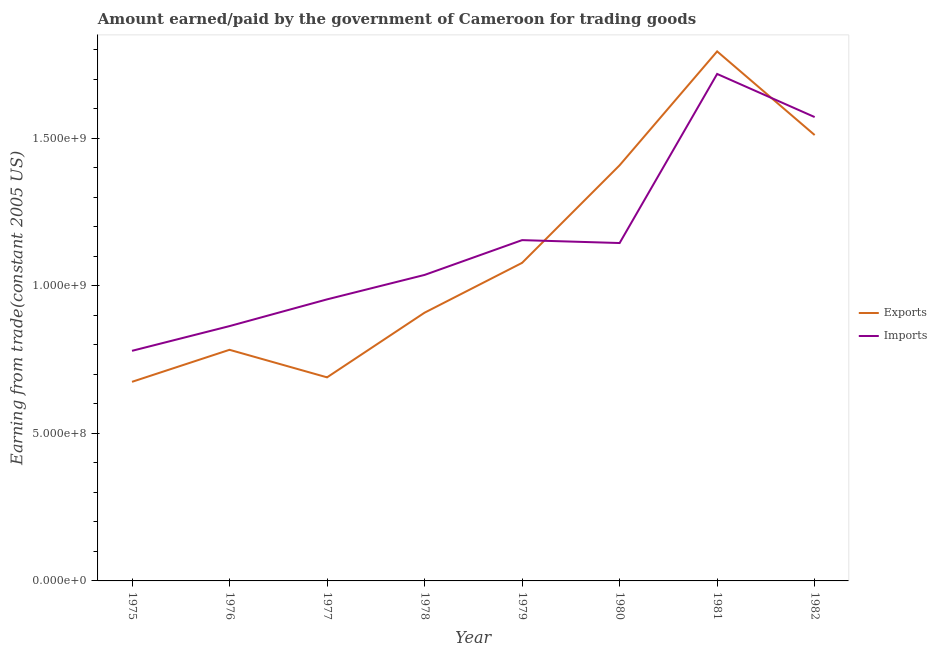Does the line corresponding to amount paid for imports intersect with the line corresponding to amount earned from exports?
Offer a very short reply. Yes. Is the number of lines equal to the number of legend labels?
Provide a succinct answer. Yes. What is the amount earned from exports in 1982?
Provide a succinct answer. 1.51e+09. Across all years, what is the maximum amount paid for imports?
Provide a succinct answer. 1.72e+09. Across all years, what is the minimum amount paid for imports?
Provide a short and direct response. 7.79e+08. In which year was the amount earned from exports minimum?
Make the answer very short. 1975. What is the total amount paid for imports in the graph?
Make the answer very short. 9.22e+09. What is the difference between the amount earned from exports in 1975 and that in 1982?
Ensure brevity in your answer.  -8.36e+08. What is the difference between the amount paid for imports in 1982 and the amount earned from exports in 1978?
Your response must be concise. 6.63e+08. What is the average amount earned from exports per year?
Offer a terse response. 1.11e+09. In the year 1980, what is the difference between the amount paid for imports and amount earned from exports?
Provide a short and direct response. -2.63e+08. In how many years, is the amount paid for imports greater than 1200000000 US$?
Provide a succinct answer. 2. What is the ratio of the amount paid for imports in 1975 to that in 1978?
Ensure brevity in your answer.  0.75. Is the difference between the amount earned from exports in 1977 and 1979 greater than the difference between the amount paid for imports in 1977 and 1979?
Your response must be concise. No. What is the difference between the highest and the second highest amount earned from exports?
Make the answer very short. 2.83e+08. What is the difference between the highest and the lowest amount paid for imports?
Make the answer very short. 9.38e+08. Is the sum of the amount paid for imports in 1975 and 1977 greater than the maximum amount earned from exports across all years?
Your response must be concise. No. Does the amount paid for imports monotonically increase over the years?
Offer a terse response. No. Is the amount paid for imports strictly less than the amount earned from exports over the years?
Keep it short and to the point. No. How many lines are there?
Give a very brief answer. 2. How many years are there in the graph?
Offer a terse response. 8. Does the graph contain grids?
Offer a terse response. No. Where does the legend appear in the graph?
Provide a succinct answer. Center right. How many legend labels are there?
Give a very brief answer. 2. How are the legend labels stacked?
Give a very brief answer. Vertical. What is the title of the graph?
Give a very brief answer. Amount earned/paid by the government of Cameroon for trading goods. Does "Banks" appear as one of the legend labels in the graph?
Offer a terse response. No. What is the label or title of the X-axis?
Keep it short and to the point. Year. What is the label or title of the Y-axis?
Make the answer very short. Earning from trade(constant 2005 US). What is the Earning from trade(constant 2005 US) in Exports in 1975?
Give a very brief answer. 6.74e+08. What is the Earning from trade(constant 2005 US) of Imports in 1975?
Your answer should be compact. 7.79e+08. What is the Earning from trade(constant 2005 US) of Exports in 1976?
Your answer should be very brief. 7.83e+08. What is the Earning from trade(constant 2005 US) of Imports in 1976?
Provide a succinct answer. 8.63e+08. What is the Earning from trade(constant 2005 US) in Exports in 1977?
Keep it short and to the point. 6.90e+08. What is the Earning from trade(constant 2005 US) of Imports in 1977?
Your response must be concise. 9.54e+08. What is the Earning from trade(constant 2005 US) in Exports in 1978?
Make the answer very short. 9.09e+08. What is the Earning from trade(constant 2005 US) of Imports in 1978?
Offer a very short reply. 1.04e+09. What is the Earning from trade(constant 2005 US) of Exports in 1979?
Give a very brief answer. 1.08e+09. What is the Earning from trade(constant 2005 US) of Imports in 1979?
Offer a terse response. 1.15e+09. What is the Earning from trade(constant 2005 US) of Exports in 1980?
Give a very brief answer. 1.41e+09. What is the Earning from trade(constant 2005 US) of Imports in 1980?
Provide a short and direct response. 1.14e+09. What is the Earning from trade(constant 2005 US) of Exports in 1981?
Ensure brevity in your answer.  1.79e+09. What is the Earning from trade(constant 2005 US) of Imports in 1981?
Your answer should be very brief. 1.72e+09. What is the Earning from trade(constant 2005 US) of Exports in 1982?
Your answer should be very brief. 1.51e+09. What is the Earning from trade(constant 2005 US) in Imports in 1982?
Give a very brief answer. 1.57e+09. Across all years, what is the maximum Earning from trade(constant 2005 US) of Exports?
Provide a short and direct response. 1.79e+09. Across all years, what is the maximum Earning from trade(constant 2005 US) in Imports?
Your answer should be compact. 1.72e+09. Across all years, what is the minimum Earning from trade(constant 2005 US) in Exports?
Ensure brevity in your answer.  6.74e+08. Across all years, what is the minimum Earning from trade(constant 2005 US) of Imports?
Give a very brief answer. 7.79e+08. What is the total Earning from trade(constant 2005 US) of Exports in the graph?
Your response must be concise. 8.84e+09. What is the total Earning from trade(constant 2005 US) of Imports in the graph?
Make the answer very short. 9.22e+09. What is the difference between the Earning from trade(constant 2005 US) of Exports in 1975 and that in 1976?
Your answer should be compact. -1.08e+08. What is the difference between the Earning from trade(constant 2005 US) in Imports in 1975 and that in 1976?
Your answer should be compact. -8.37e+07. What is the difference between the Earning from trade(constant 2005 US) of Exports in 1975 and that in 1977?
Keep it short and to the point. -1.51e+07. What is the difference between the Earning from trade(constant 2005 US) in Imports in 1975 and that in 1977?
Give a very brief answer. -1.74e+08. What is the difference between the Earning from trade(constant 2005 US) in Exports in 1975 and that in 1978?
Your answer should be compact. -2.34e+08. What is the difference between the Earning from trade(constant 2005 US) of Imports in 1975 and that in 1978?
Your answer should be compact. -2.57e+08. What is the difference between the Earning from trade(constant 2005 US) of Exports in 1975 and that in 1979?
Offer a terse response. -4.03e+08. What is the difference between the Earning from trade(constant 2005 US) in Imports in 1975 and that in 1979?
Your answer should be very brief. -3.75e+08. What is the difference between the Earning from trade(constant 2005 US) in Exports in 1975 and that in 1980?
Provide a succinct answer. -7.33e+08. What is the difference between the Earning from trade(constant 2005 US) in Imports in 1975 and that in 1980?
Give a very brief answer. -3.65e+08. What is the difference between the Earning from trade(constant 2005 US) of Exports in 1975 and that in 1981?
Ensure brevity in your answer.  -1.12e+09. What is the difference between the Earning from trade(constant 2005 US) of Imports in 1975 and that in 1981?
Offer a terse response. -9.38e+08. What is the difference between the Earning from trade(constant 2005 US) in Exports in 1975 and that in 1982?
Provide a succinct answer. -8.36e+08. What is the difference between the Earning from trade(constant 2005 US) in Imports in 1975 and that in 1982?
Your answer should be very brief. -7.92e+08. What is the difference between the Earning from trade(constant 2005 US) of Exports in 1976 and that in 1977?
Ensure brevity in your answer.  9.33e+07. What is the difference between the Earning from trade(constant 2005 US) in Imports in 1976 and that in 1977?
Keep it short and to the point. -9.05e+07. What is the difference between the Earning from trade(constant 2005 US) of Exports in 1976 and that in 1978?
Provide a succinct answer. -1.26e+08. What is the difference between the Earning from trade(constant 2005 US) of Imports in 1976 and that in 1978?
Your answer should be very brief. -1.73e+08. What is the difference between the Earning from trade(constant 2005 US) of Exports in 1976 and that in 1979?
Ensure brevity in your answer.  -2.94e+08. What is the difference between the Earning from trade(constant 2005 US) in Imports in 1976 and that in 1979?
Make the answer very short. -2.91e+08. What is the difference between the Earning from trade(constant 2005 US) of Exports in 1976 and that in 1980?
Offer a terse response. -6.25e+08. What is the difference between the Earning from trade(constant 2005 US) of Imports in 1976 and that in 1980?
Offer a very short reply. -2.81e+08. What is the difference between the Earning from trade(constant 2005 US) of Exports in 1976 and that in 1981?
Offer a terse response. -1.01e+09. What is the difference between the Earning from trade(constant 2005 US) of Imports in 1976 and that in 1981?
Your answer should be compact. -8.54e+08. What is the difference between the Earning from trade(constant 2005 US) of Exports in 1976 and that in 1982?
Offer a very short reply. -7.27e+08. What is the difference between the Earning from trade(constant 2005 US) in Imports in 1976 and that in 1982?
Keep it short and to the point. -7.08e+08. What is the difference between the Earning from trade(constant 2005 US) of Exports in 1977 and that in 1978?
Make the answer very short. -2.19e+08. What is the difference between the Earning from trade(constant 2005 US) in Imports in 1977 and that in 1978?
Provide a short and direct response. -8.28e+07. What is the difference between the Earning from trade(constant 2005 US) of Exports in 1977 and that in 1979?
Keep it short and to the point. -3.88e+08. What is the difference between the Earning from trade(constant 2005 US) in Imports in 1977 and that in 1979?
Offer a terse response. -2.01e+08. What is the difference between the Earning from trade(constant 2005 US) in Exports in 1977 and that in 1980?
Give a very brief answer. -7.18e+08. What is the difference between the Earning from trade(constant 2005 US) of Imports in 1977 and that in 1980?
Give a very brief answer. -1.91e+08. What is the difference between the Earning from trade(constant 2005 US) in Exports in 1977 and that in 1981?
Keep it short and to the point. -1.10e+09. What is the difference between the Earning from trade(constant 2005 US) of Imports in 1977 and that in 1981?
Offer a terse response. -7.64e+08. What is the difference between the Earning from trade(constant 2005 US) in Exports in 1977 and that in 1982?
Offer a very short reply. -8.21e+08. What is the difference between the Earning from trade(constant 2005 US) of Imports in 1977 and that in 1982?
Provide a succinct answer. -6.18e+08. What is the difference between the Earning from trade(constant 2005 US) of Exports in 1978 and that in 1979?
Provide a succinct answer. -1.69e+08. What is the difference between the Earning from trade(constant 2005 US) of Imports in 1978 and that in 1979?
Offer a terse response. -1.18e+08. What is the difference between the Earning from trade(constant 2005 US) of Exports in 1978 and that in 1980?
Offer a terse response. -4.99e+08. What is the difference between the Earning from trade(constant 2005 US) in Imports in 1978 and that in 1980?
Offer a terse response. -1.08e+08. What is the difference between the Earning from trade(constant 2005 US) in Exports in 1978 and that in 1981?
Your answer should be very brief. -8.85e+08. What is the difference between the Earning from trade(constant 2005 US) of Imports in 1978 and that in 1981?
Provide a succinct answer. -6.81e+08. What is the difference between the Earning from trade(constant 2005 US) in Exports in 1978 and that in 1982?
Provide a succinct answer. -6.02e+08. What is the difference between the Earning from trade(constant 2005 US) in Imports in 1978 and that in 1982?
Your response must be concise. -5.35e+08. What is the difference between the Earning from trade(constant 2005 US) in Exports in 1979 and that in 1980?
Provide a short and direct response. -3.31e+08. What is the difference between the Earning from trade(constant 2005 US) in Imports in 1979 and that in 1980?
Make the answer very short. 9.83e+06. What is the difference between the Earning from trade(constant 2005 US) in Exports in 1979 and that in 1981?
Your answer should be very brief. -7.16e+08. What is the difference between the Earning from trade(constant 2005 US) in Imports in 1979 and that in 1981?
Ensure brevity in your answer.  -5.63e+08. What is the difference between the Earning from trade(constant 2005 US) of Exports in 1979 and that in 1982?
Offer a terse response. -4.33e+08. What is the difference between the Earning from trade(constant 2005 US) in Imports in 1979 and that in 1982?
Keep it short and to the point. -4.17e+08. What is the difference between the Earning from trade(constant 2005 US) of Exports in 1980 and that in 1981?
Keep it short and to the point. -3.86e+08. What is the difference between the Earning from trade(constant 2005 US) of Imports in 1980 and that in 1981?
Your response must be concise. -5.73e+08. What is the difference between the Earning from trade(constant 2005 US) in Exports in 1980 and that in 1982?
Keep it short and to the point. -1.02e+08. What is the difference between the Earning from trade(constant 2005 US) of Imports in 1980 and that in 1982?
Offer a terse response. -4.27e+08. What is the difference between the Earning from trade(constant 2005 US) in Exports in 1981 and that in 1982?
Provide a succinct answer. 2.83e+08. What is the difference between the Earning from trade(constant 2005 US) of Imports in 1981 and that in 1982?
Provide a succinct answer. 1.46e+08. What is the difference between the Earning from trade(constant 2005 US) of Exports in 1975 and the Earning from trade(constant 2005 US) of Imports in 1976?
Give a very brief answer. -1.89e+08. What is the difference between the Earning from trade(constant 2005 US) of Exports in 1975 and the Earning from trade(constant 2005 US) of Imports in 1977?
Offer a terse response. -2.79e+08. What is the difference between the Earning from trade(constant 2005 US) of Exports in 1975 and the Earning from trade(constant 2005 US) of Imports in 1978?
Your answer should be compact. -3.62e+08. What is the difference between the Earning from trade(constant 2005 US) in Exports in 1975 and the Earning from trade(constant 2005 US) in Imports in 1979?
Make the answer very short. -4.80e+08. What is the difference between the Earning from trade(constant 2005 US) of Exports in 1975 and the Earning from trade(constant 2005 US) of Imports in 1980?
Your answer should be very brief. -4.70e+08. What is the difference between the Earning from trade(constant 2005 US) in Exports in 1975 and the Earning from trade(constant 2005 US) in Imports in 1981?
Make the answer very short. -1.04e+09. What is the difference between the Earning from trade(constant 2005 US) of Exports in 1975 and the Earning from trade(constant 2005 US) of Imports in 1982?
Offer a terse response. -8.97e+08. What is the difference between the Earning from trade(constant 2005 US) of Exports in 1976 and the Earning from trade(constant 2005 US) of Imports in 1977?
Provide a succinct answer. -1.71e+08. What is the difference between the Earning from trade(constant 2005 US) in Exports in 1976 and the Earning from trade(constant 2005 US) in Imports in 1978?
Offer a terse response. -2.54e+08. What is the difference between the Earning from trade(constant 2005 US) of Exports in 1976 and the Earning from trade(constant 2005 US) of Imports in 1979?
Ensure brevity in your answer.  -3.71e+08. What is the difference between the Earning from trade(constant 2005 US) of Exports in 1976 and the Earning from trade(constant 2005 US) of Imports in 1980?
Provide a succinct answer. -3.62e+08. What is the difference between the Earning from trade(constant 2005 US) of Exports in 1976 and the Earning from trade(constant 2005 US) of Imports in 1981?
Give a very brief answer. -9.34e+08. What is the difference between the Earning from trade(constant 2005 US) of Exports in 1976 and the Earning from trade(constant 2005 US) of Imports in 1982?
Offer a very short reply. -7.88e+08. What is the difference between the Earning from trade(constant 2005 US) of Exports in 1977 and the Earning from trade(constant 2005 US) of Imports in 1978?
Keep it short and to the point. -3.47e+08. What is the difference between the Earning from trade(constant 2005 US) in Exports in 1977 and the Earning from trade(constant 2005 US) in Imports in 1979?
Provide a short and direct response. -4.65e+08. What is the difference between the Earning from trade(constant 2005 US) in Exports in 1977 and the Earning from trade(constant 2005 US) in Imports in 1980?
Ensure brevity in your answer.  -4.55e+08. What is the difference between the Earning from trade(constant 2005 US) of Exports in 1977 and the Earning from trade(constant 2005 US) of Imports in 1981?
Your response must be concise. -1.03e+09. What is the difference between the Earning from trade(constant 2005 US) in Exports in 1977 and the Earning from trade(constant 2005 US) in Imports in 1982?
Provide a succinct answer. -8.82e+08. What is the difference between the Earning from trade(constant 2005 US) in Exports in 1978 and the Earning from trade(constant 2005 US) in Imports in 1979?
Your response must be concise. -2.46e+08. What is the difference between the Earning from trade(constant 2005 US) of Exports in 1978 and the Earning from trade(constant 2005 US) of Imports in 1980?
Your answer should be compact. -2.36e+08. What is the difference between the Earning from trade(constant 2005 US) of Exports in 1978 and the Earning from trade(constant 2005 US) of Imports in 1981?
Ensure brevity in your answer.  -8.09e+08. What is the difference between the Earning from trade(constant 2005 US) in Exports in 1978 and the Earning from trade(constant 2005 US) in Imports in 1982?
Your answer should be compact. -6.63e+08. What is the difference between the Earning from trade(constant 2005 US) in Exports in 1979 and the Earning from trade(constant 2005 US) in Imports in 1980?
Offer a very short reply. -6.72e+07. What is the difference between the Earning from trade(constant 2005 US) in Exports in 1979 and the Earning from trade(constant 2005 US) in Imports in 1981?
Your answer should be very brief. -6.40e+08. What is the difference between the Earning from trade(constant 2005 US) in Exports in 1979 and the Earning from trade(constant 2005 US) in Imports in 1982?
Ensure brevity in your answer.  -4.94e+08. What is the difference between the Earning from trade(constant 2005 US) of Exports in 1980 and the Earning from trade(constant 2005 US) of Imports in 1981?
Provide a succinct answer. -3.09e+08. What is the difference between the Earning from trade(constant 2005 US) of Exports in 1980 and the Earning from trade(constant 2005 US) of Imports in 1982?
Offer a terse response. -1.63e+08. What is the difference between the Earning from trade(constant 2005 US) in Exports in 1981 and the Earning from trade(constant 2005 US) in Imports in 1982?
Your response must be concise. 2.22e+08. What is the average Earning from trade(constant 2005 US) of Exports per year?
Offer a very short reply. 1.11e+09. What is the average Earning from trade(constant 2005 US) in Imports per year?
Offer a very short reply. 1.15e+09. In the year 1975, what is the difference between the Earning from trade(constant 2005 US) in Exports and Earning from trade(constant 2005 US) in Imports?
Keep it short and to the point. -1.05e+08. In the year 1976, what is the difference between the Earning from trade(constant 2005 US) in Exports and Earning from trade(constant 2005 US) in Imports?
Your answer should be compact. -8.03e+07. In the year 1977, what is the difference between the Earning from trade(constant 2005 US) in Exports and Earning from trade(constant 2005 US) in Imports?
Your answer should be very brief. -2.64e+08. In the year 1978, what is the difference between the Earning from trade(constant 2005 US) of Exports and Earning from trade(constant 2005 US) of Imports?
Offer a terse response. -1.28e+08. In the year 1979, what is the difference between the Earning from trade(constant 2005 US) of Exports and Earning from trade(constant 2005 US) of Imports?
Keep it short and to the point. -7.70e+07. In the year 1980, what is the difference between the Earning from trade(constant 2005 US) in Exports and Earning from trade(constant 2005 US) in Imports?
Provide a short and direct response. 2.63e+08. In the year 1981, what is the difference between the Earning from trade(constant 2005 US) in Exports and Earning from trade(constant 2005 US) in Imports?
Provide a short and direct response. 7.64e+07. In the year 1982, what is the difference between the Earning from trade(constant 2005 US) in Exports and Earning from trade(constant 2005 US) in Imports?
Make the answer very short. -6.09e+07. What is the ratio of the Earning from trade(constant 2005 US) of Exports in 1975 to that in 1976?
Your answer should be very brief. 0.86. What is the ratio of the Earning from trade(constant 2005 US) in Imports in 1975 to that in 1976?
Provide a short and direct response. 0.9. What is the ratio of the Earning from trade(constant 2005 US) of Imports in 1975 to that in 1977?
Provide a short and direct response. 0.82. What is the ratio of the Earning from trade(constant 2005 US) of Exports in 1975 to that in 1978?
Give a very brief answer. 0.74. What is the ratio of the Earning from trade(constant 2005 US) of Imports in 1975 to that in 1978?
Keep it short and to the point. 0.75. What is the ratio of the Earning from trade(constant 2005 US) of Exports in 1975 to that in 1979?
Provide a short and direct response. 0.63. What is the ratio of the Earning from trade(constant 2005 US) of Imports in 1975 to that in 1979?
Provide a succinct answer. 0.68. What is the ratio of the Earning from trade(constant 2005 US) in Exports in 1975 to that in 1980?
Give a very brief answer. 0.48. What is the ratio of the Earning from trade(constant 2005 US) in Imports in 1975 to that in 1980?
Offer a very short reply. 0.68. What is the ratio of the Earning from trade(constant 2005 US) in Exports in 1975 to that in 1981?
Ensure brevity in your answer.  0.38. What is the ratio of the Earning from trade(constant 2005 US) of Imports in 1975 to that in 1981?
Offer a terse response. 0.45. What is the ratio of the Earning from trade(constant 2005 US) in Exports in 1975 to that in 1982?
Offer a terse response. 0.45. What is the ratio of the Earning from trade(constant 2005 US) in Imports in 1975 to that in 1982?
Make the answer very short. 0.5. What is the ratio of the Earning from trade(constant 2005 US) in Exports in 1976 to that in 1977?
Provide a succinct answer. 1.14. What is the ratio of the Earning from trade(constant 2005 US) of Imports in 1976 to that in 1977?
Your answer should be compact. 0.91. What is the ratio of the Earning from trade(constant 2005 US) of Exports in 1976 to that in 1978?
Give a very brief answer. 0.86. What is the ratio of the Earning from trade(constant 2005 US) in Imports in 1976 to that in 1978?
Keep it short and to the point. 0.83. What is the ratio of the Earning from trade(constant 2005 US) in Exports in 1976 to that in 1979?
Provide a short and direct response. 0.73. What is the ratio of the Earning from trade(constant 2005 US) in Imports in 1976 to that in 1979?
Give a very brief answer. 0.75. What is the ratio of the Earning from trade(constant 2005 US) of Exports in 1976 to that in 1980?
Keep it short and to the point. 0.56. What is the ratio of the Earning from trade(constant 2005 US) of Imports in 1976 to that in 1980?
Ensure brevity in your answer.  0.75. What is the ratio of the Earning from trade(constant 2005 US) in Exports in 1976 to that in 1981?
Give a very brief answer. 0.44. What is the ratio of the Earning from trade(constant 2005 US) of Imports in 1976 to that in 1981?
Keep it short and to the point. 0.5. What is the ratio of the Earning from trade(constant 2005 US) of Exports in 1976 to that in 1982?
Ensure brevity in your answer.  0.52. What is the ratio of the Earning from trade(constant 2005 US) in Imports in 1976 to that in 1982?
Give a very brief answer. 0.55. What is the ratio of the Earning from trade(constant 2005 US) in Exports in 1977 to that in 1978?
Provide a short and direct response. 0.76. What is the ratio of the Earning from trade(constant 2005 US) in Imports in 1977 to that in 1978?
Provide a succinct answer. 0.92. What is the ratio of the Earning from trade(constant 2005 US) of Exports in 1977 to that in 1979?
Make the answer very short. 0.64. What is the ratio of the Earning from trade(constant 2005 US) in Imports in 1977 to that in 1979?
Offer a very short reply. 0.83. What is the ratio of the Earning from trade(constant 2005 US) of Exports in 1977 to that in 1980?
Provide a short and direct response. 0.49. What is the ratio of the Earning from trade(constant 2005 US) of Imports in 1977 to that in 1980?
Your answer should be very brief. 0.83. What is the ratio of the Earning from trade(constant 2005 US) of Exports in 1977 to that in 1981?
Keep it short and to the point. 0.38. What is the ratio of the Earning from trade(constant 2005 US) in Imports in 1977 to that in 1981?
Offer a very short reply. 0.56. What is the ratio of the Earning from trade(constant 2005 US) in Exports in 1977 to that in 1982?
Provide a succinct answer. 0.46. What is the ratio of the Earning from trade(constant 2005 US) in Imports in 1977 to that in 1982?
Your response must be concise. 0.61. What is the ratio of the Earning from trade(constant 2005 US) of Exports in 1978 to that in 1979?
Your response must be concise. 0.84. What is the ratio of the Earning from trade(constant 2005 US) in Imports in 1978 to that in 1979?
Your response must be concise. 0.9. What is the ratio of the Earning from trade(constant 2005 US) of Exports in 1978 to that in 1980?
Keep it short and to the point. 0.65. What is the ratio of the Earning from trade(constant 2005 US) in Imports in 1978 to that in 1980?
Provide a short and direct response. 0.91. What is the ratio of the Earning from trade(constant 2005 US) of Exports in 1978 to that in 1981?
Offer a terse response. 0.51. What is the ratio of the Earning from trade(constant 2005 US) of Imports in 1978 to that in 1981?
Make the answer very short. 0.6. What is the ratio of the Earning from trade(constant 2005 US) in Exports in 1978 to that in 1982?
Make the answer very short. 0.6. What is the ratio of the Earning from trade(constant 2005 US) in Imports in 1978 to that in 1982?
Your response must be concise. 0.66. What is the ratio of the Earning from trade(constant 2005 US) in Exports in 1979 to that in 1980?
Give a very brief answer. 0.77. What is the ratio of the Earning from trade(constant 2005 US) in Imports in 1979 to that in 1980?
Ensure brevity in your answer.  1.01. What is the ratio of the Earning from trade(constant 2005 US) of Exports in 1979 to that in 1981?
Offer a terse response. 0.6. What is the ratio of the Earning from trade(constant 2005 US) in Imports in 1979 to that in 1981?
Give a very brief answer. 0.67. What is the ratio of the Earning from trade(constant 2005 US) of Exports in 1979 to that in 1982?
Ensure brevity in your answer.  0.71. What is the ratio of the Earning from trade(constant 2005 US) of Imports in 1979 to that in 1982?
Provide a short and direct response. 0.73. What is the ratio of the Earning from trade(constant 2005 US) in Exports in 1980 to that in 1981?
Offer a terse response. 0.78. What is the ratio of the Earning from trade(constant 2005 US) in Imports in 1980 to that in 1981?
Make the answer very short. 0.67. What is the ratio of the Earning from trade(constant 2005 US) of Exports in 1980 to that in 1982?
Your response must be concise. 0.93. What is the ratio of the Earning from trade(constant 2005 US) in Imports in 1980 to that in 1982?
Provide a succinct answer. 0.73. What is the ratio of the Earning from trade(constant 2005 US) in Exports in 1981 to that in 1982?
Give a very brief answer. 1.19. What is the ratio of the Earning from trade(constant 2005 US) in Imports in 1981 to that in 1982?
Your response must be concise. 1.09. What is the difference between the highest and the second highest Earning from trade(constant 2005 US) in Exports?
Keep it short and to the point. 2.83e+08. What is the difference between the highest and the second highest Earning from trade(constant 2005 US) of Imports?
Ensure brevity in your answer.  1.46e+08. What is the difference between the highest and the lowest Earning from trade(constant 2005 US) in Exports?
Offer a terse response. 1.12e+09. What is the difference between the highest and the lowest Earning from trade(constant 2005 US) in Imports?
Your answer should be very brief. 9.38e+08. 